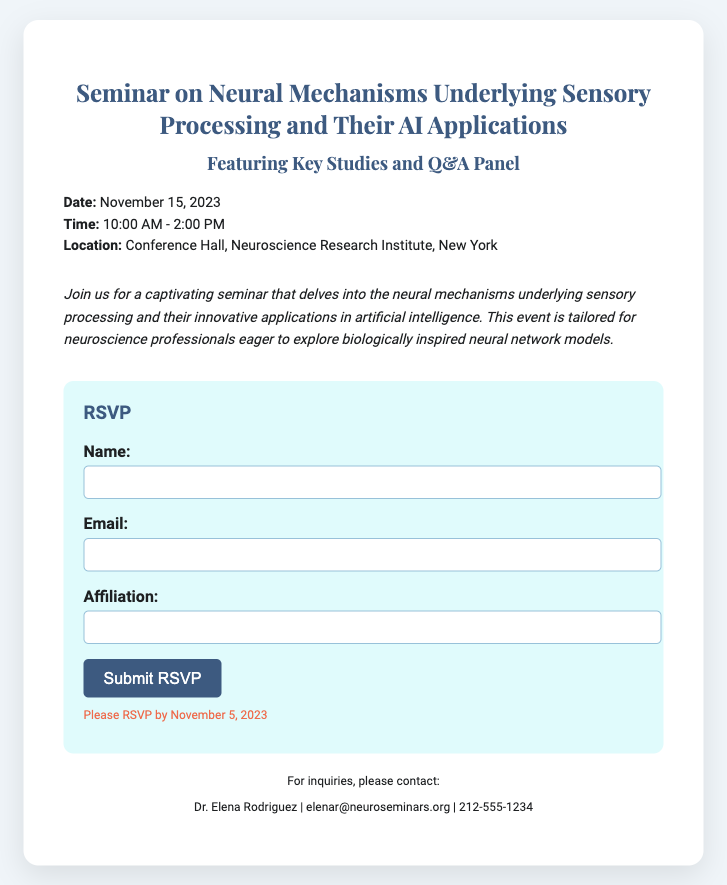What is the date of the seminar? The date of the seminar is explicitly mentioned in the document.
Answer: November 15, 2023 What time does the seminar start? The start time for the seminar is stated in the details section of the document.
Answer: 10:00 AM Where is the seminar located? The location is provided in the details section of the document.
Answer: Conference Hall, Neuroscience Research Institute, New York What is the deadline to RSVP? The RSVP deadline is clearly mentioned towards the end of the document.
Answer: November 5, 2023 Who can be contacted for inquiries? The contact information is provided in the contact section of the document.
Answer: Dr. Elena Rodriguez What is the main topic of the seminar? The main topic of the seminar is summarized in the description section of the document.
Answer: Neural mechanisms underlying sensory processing How long will the seminar last? The duration can be inferred from the start and end times noted in the document.
Answer: 4 hours What is the email address for submitting RSVPs? The email for RSVPs is included in the form action within the RSVP section.
Answer: rsvp@neuroseminars.org What type of event is this document promoting? The document describes the nature of the event through its title and description.
Answer: Seminar 